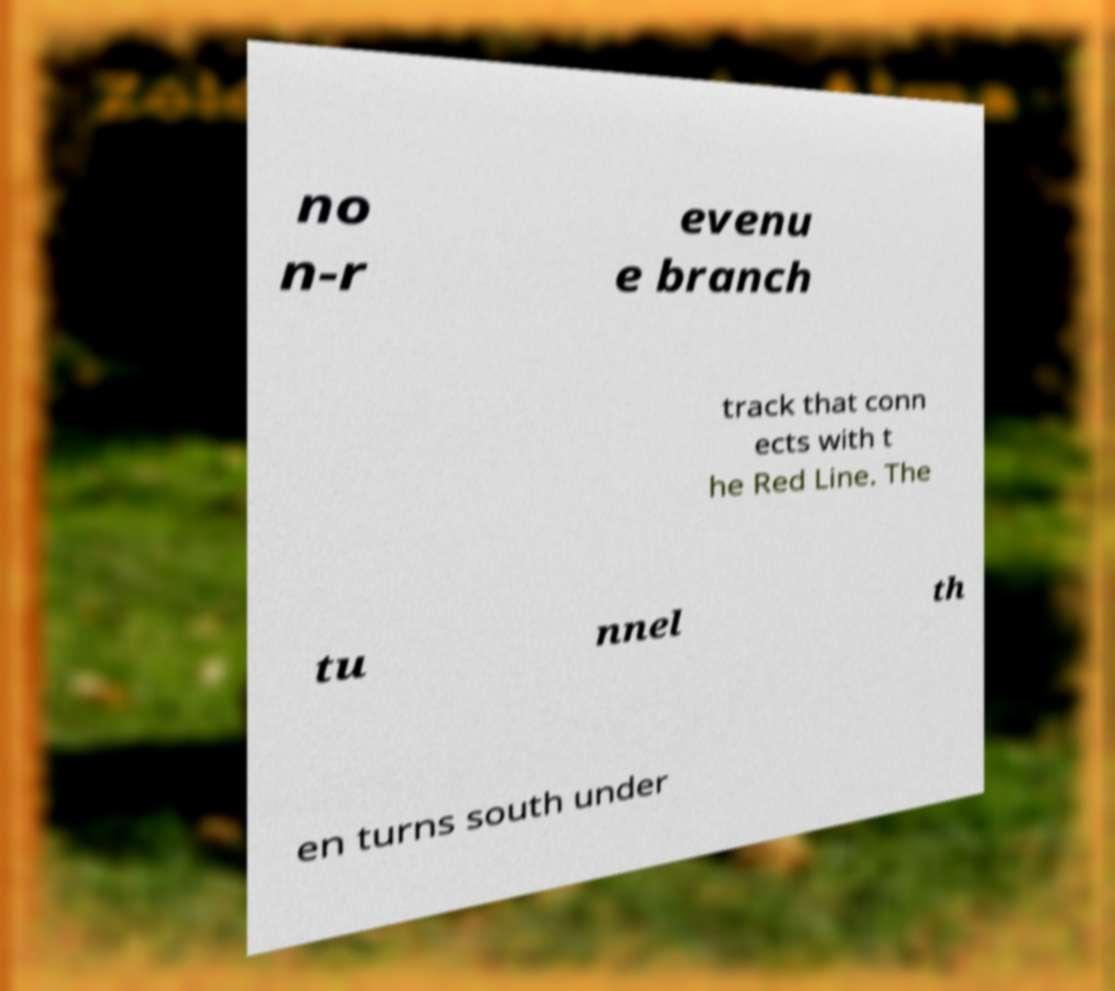Could you extract and type out the text from this image? no n-r evenu e branch track that conn ects with t he Red Line. The tu nnel th en turns south under 